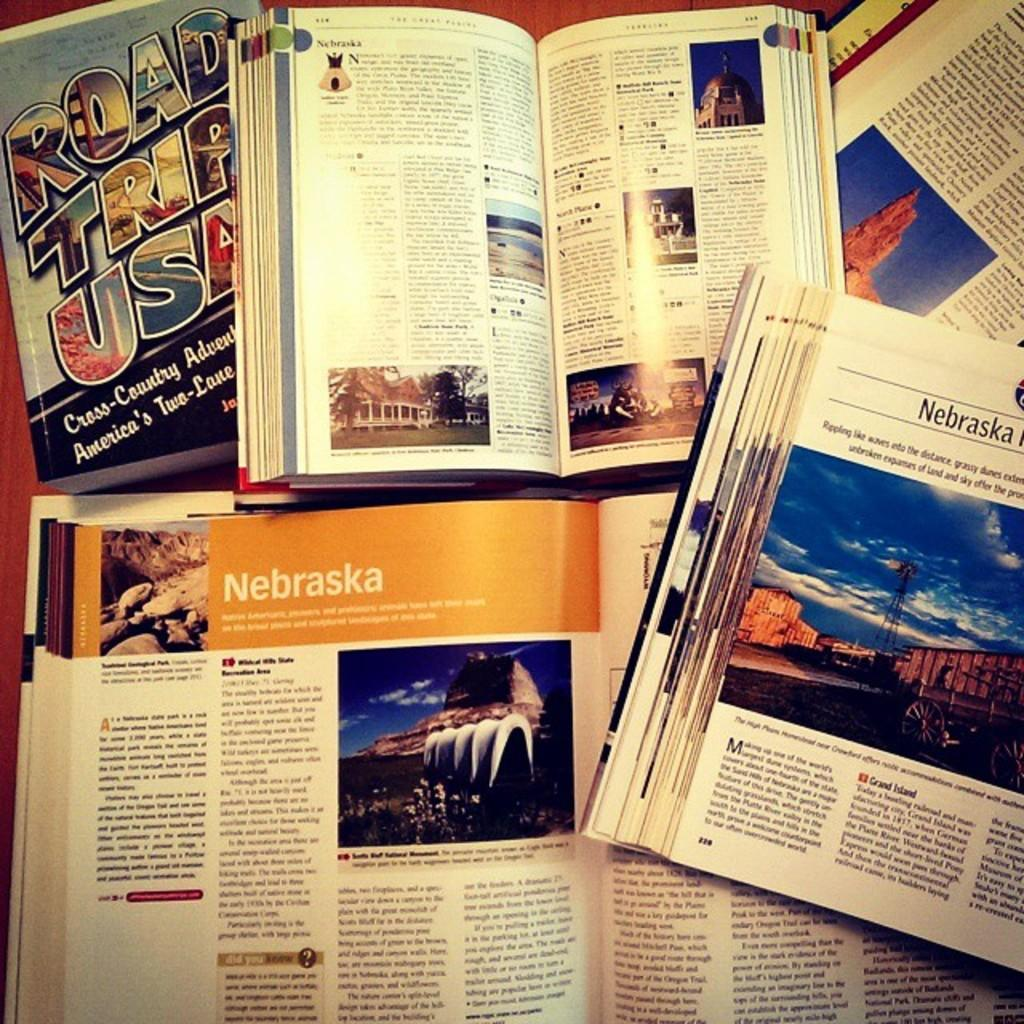<image>
Write a terse but informative summary of the picture. Different books are opened, most to articles on Nebraska. 